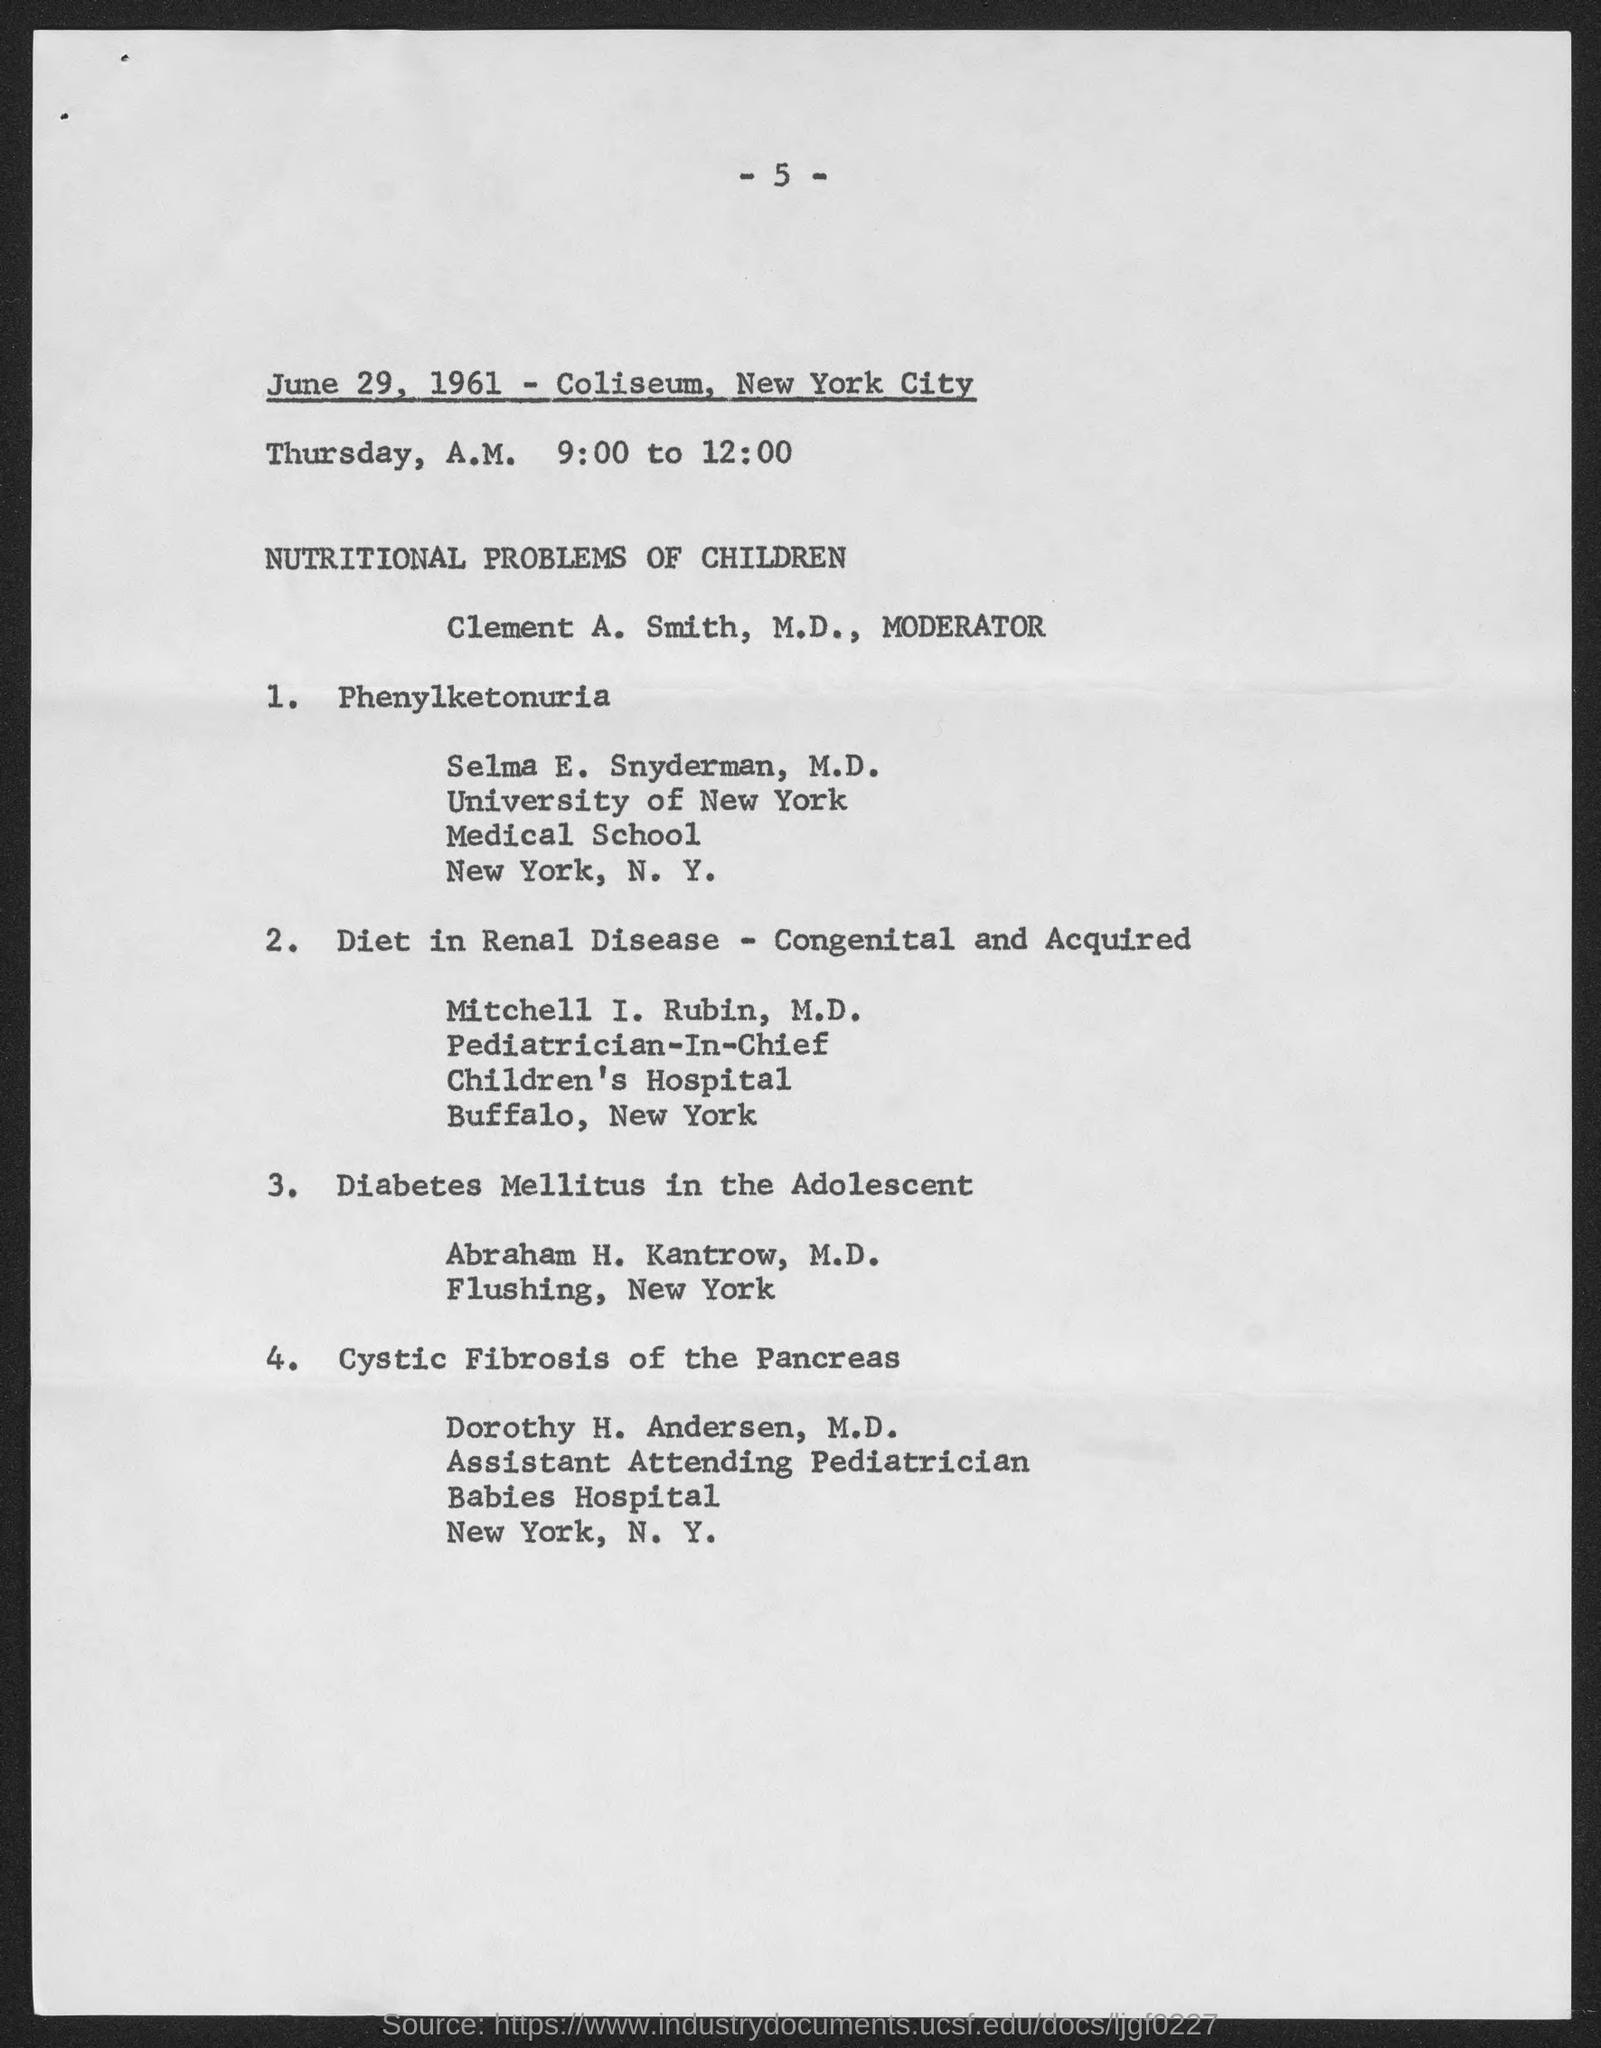Mention a couple of crucial points in this snapshot. The Coliseum is located in New York City. The Coliseum is about the nutritional problems of children and their effects on childhood development and health. On June 29, 1961, the Coliseum was held. 